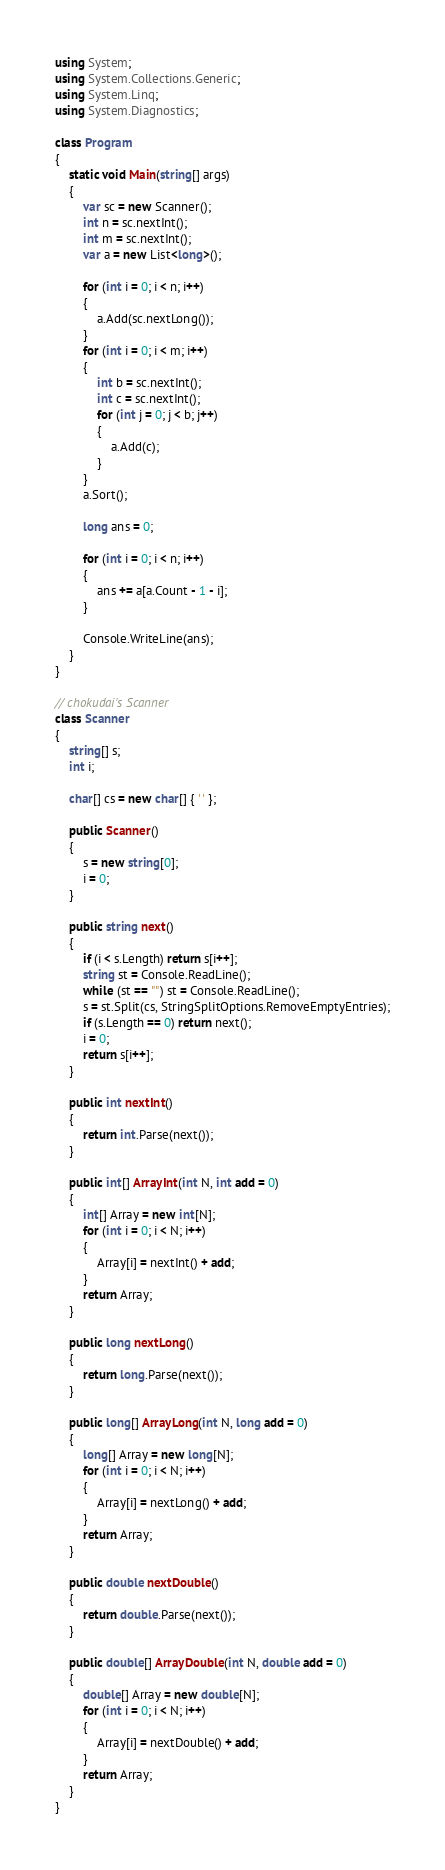Convert code to text. <code><loc_0><loc_0><loc_500><loc_500><_C#_>using System;
using System.Collections.Generic;
using System.Linq;
using System.Diagnostics;

class Program
{
    static void Main(string[] args)
    {
        var sc = new Scanner();
        int n = sc.nextInt();
        int m = sc.nextInt();
        var a = new List<long>();

        for (int i = 0; i < n; i++)
        {
            a.Add(sc.nextLong());
        }
        for (int i = 0; i < m; i++)
        {
            int b = sc.nextInt();
            int c = sc.nextInt();
            for (int j = 0; j < b; j++)
            {
                a.Add(c);
            }
        }
        a.Sort();

        long ans = 0;

        for (int i = 0; i < n; i++)
        {
            ans += a[a.Count - 1 - i];
        }

        Console.WriteLine(ans);
    }
}

// chokudai's Scanner
class Scanner
{
    string[] s;
    int i;

    char[] cs = new char[] { ' ' };

    public Scanner()
    {
        s = new string[0];
        i = 0;
    }

    public string next()
    {
        if (i < s.Length) return s[i++];
        string st = Console.ReadLine();
        while (st == "") st = Console.ReadLine();
        s = st.Split(cs, StringSplitOptions.RemoveEmptyEntries);
        if (s.Length == 0) return next();
        i = 0;
        return s[i++];
    }

    public int nextInt()
    {
        return int.Parse(next());
    }

    public int[] ArrayInt(int N, int add = 0)
    {
        int[] Array = new int[N];
        for (int i = 0; i < N; i++)
        {
            Array[i] = nextInt() + add;
        }
        return Array;
    }

    public long nextLong()
    {
        return long.Parse(next());
    }

    public long[] ArrayLong(int N, long add = 0)
    {
        long[] Array = new long[N];
        for (int i = 0; i < N; i++)
        {
            Array[i] = nextLong() + add;
        }
        return Array;
    }

    public double nextDouble()
    {
        return double.Parse(next());
    }

    public double[] ArrayDouble(int N, double add = 0)
    {
        double[] Array = new double[N];
        for (int i = 0; i < N; i++)
        {
            Array[i] = nextDouble() + add;
        }
        return Array;
    }
}
</code> 